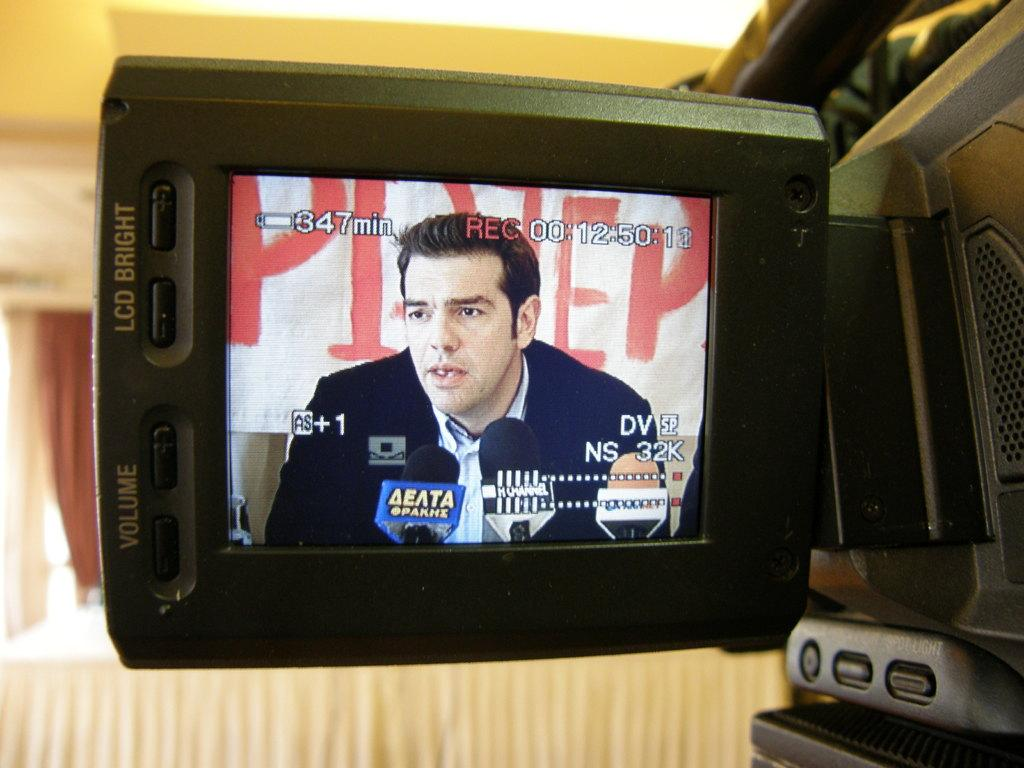Provide a one-sentence caption for the provided image. 347 minutes of battery life and 00:12:50:12 recorded time are shown on the screen. 